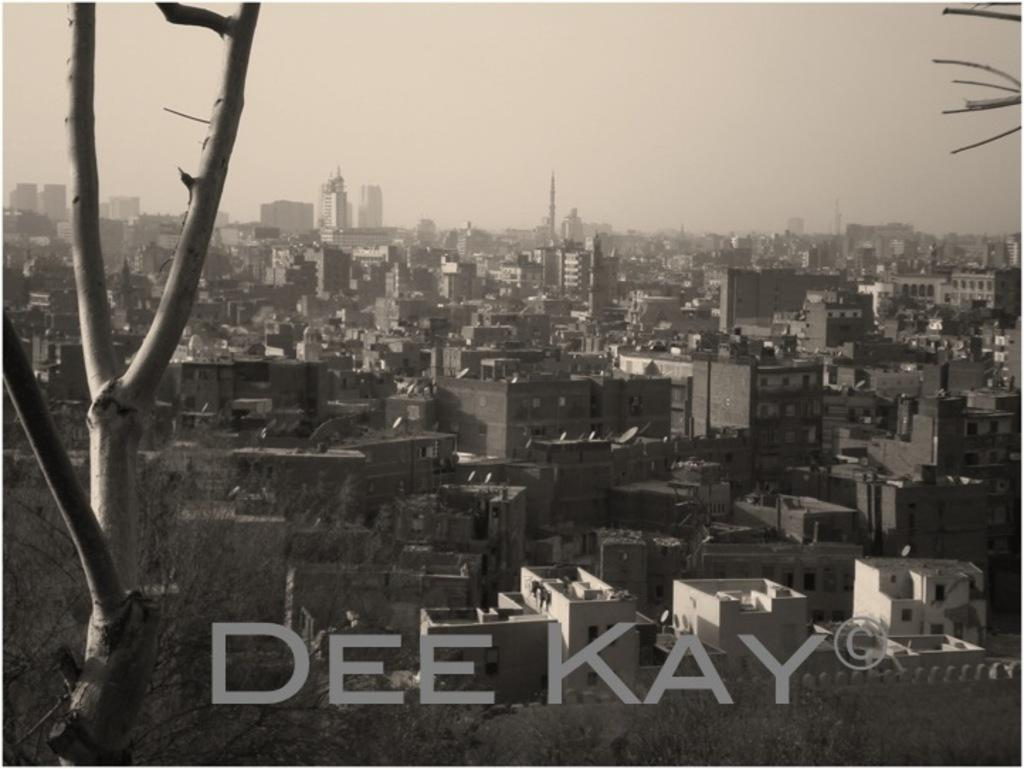What type of location is depicted in the image? The image is of a city. What structures can be seen in the city? There are buildings in the image. Are there any natural elements present in the city? Yes, there are trees in the image. What can be seen in the background of the image? The sky is visible in the background of the image. Is there a tub filled with water during the rainstorm in the image? There is no tub or rainstorm present in the image; it depicts a city with buildings, trees, and a visible sky. 